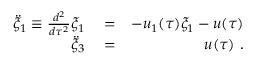Convert formula to latex. <formula><loc_0><loc_0><loc_500><loc_500>\begin{array} { r l r } { \ddot { \xi } _ { 1 } \equiv \frac { d ^ { 2 } } { d \tau ^ { 2 } } \xi _ { 1 } } & = } & { - u _ { 1 } ( \tau ) \xi _ { 1 } - u ( \tau ) } \\ { \ddot { \xi } _ { 3 } } & = } & { u ( \tau ) . } \end{array}</formula> 